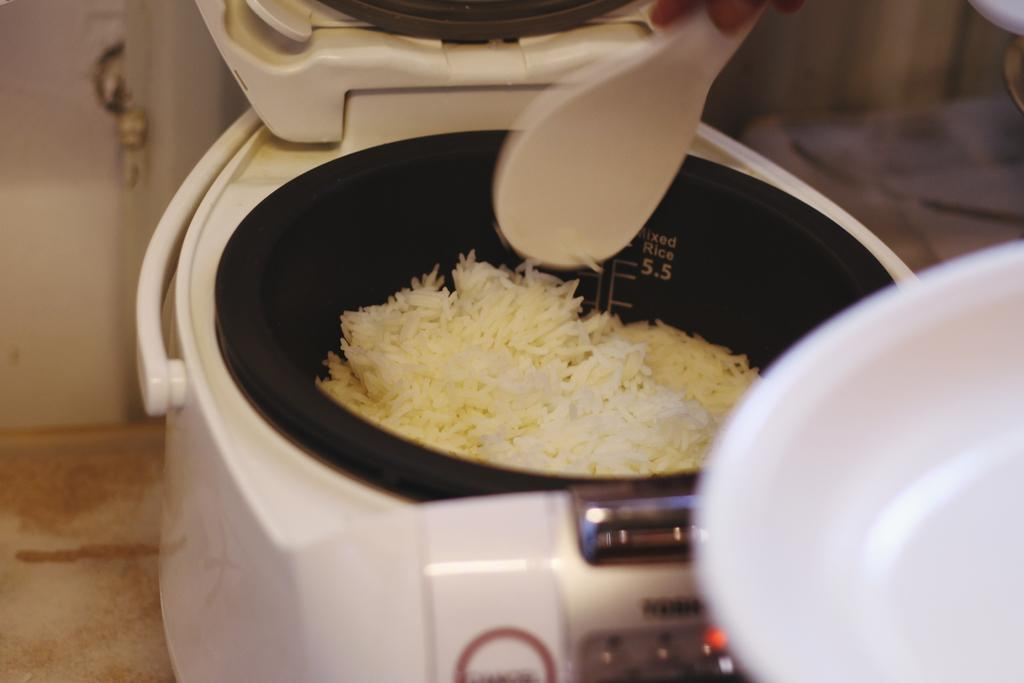<image>
Relay a brief, clear account of the picture shown. a white appliance with the number 5.5 in it 